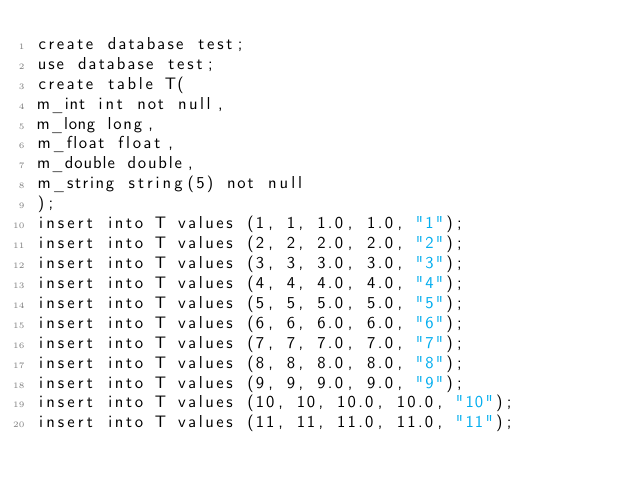<code> <loc_0><loc_0><loc_500><loc_500><_SQL_>create database test;
use database test;
create table T(
m_int int not null,
m_long long,
m_float float,
m_double double,
m_string string(5) not null
);
insert into T values (1, 1, 1.0, 1.0, "1");
insert into T values (2, 2, 2.0, 2.0, "2");
insert into T values (3, 3, 3.0, 3.0, "3");
insert into T values (4, 4, 4.0, 4.0, "4");
insert into T values (5, 5, 5.0, 5.0, "5");
insert into T values (6, 6, 6.0, 6.0, "6");
insert into T values (7, 7, 7.0, 7.0, "7");
insert into T values (8, 8, 8.0, 8.0, "8");
insert into T values (9, 9, 9.0, 9.0, "9");
insert into T values (10, 10, 10.0, 10.0, "10");
insert into T values (11, 11, 11.0, 11.0, "11");</code> 